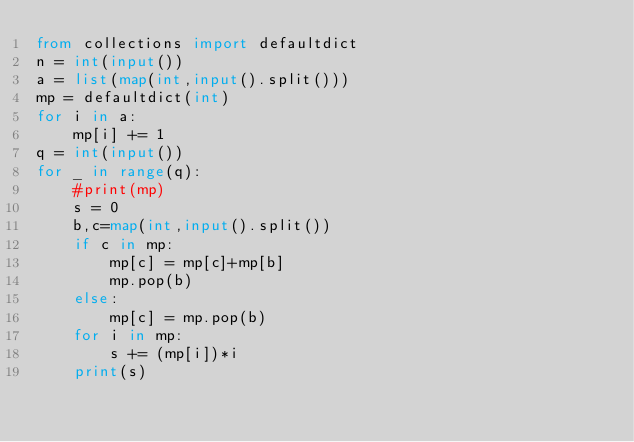Convert code to text. <code><loc_0><loc_0><loc_500><loc_500><_Python_>from collections import defaultdict
n = int(input())
a = list(map(int,input().split()))
mp = defaultdict(int)
for i in a:
    mp[i] += 1
q = int(input())
for _ in range(q):
    #print(mp)
    s = 0   
    b,c=map(int,input().split())
    if c in mp:
        mp[c] = mp[c]+mp[b]
        mp.pop(b)
    else:
        mp[c] = mp.pop(b)
    for i in mp:
        s += (mp[i])*i
    print(s)
    </code> 